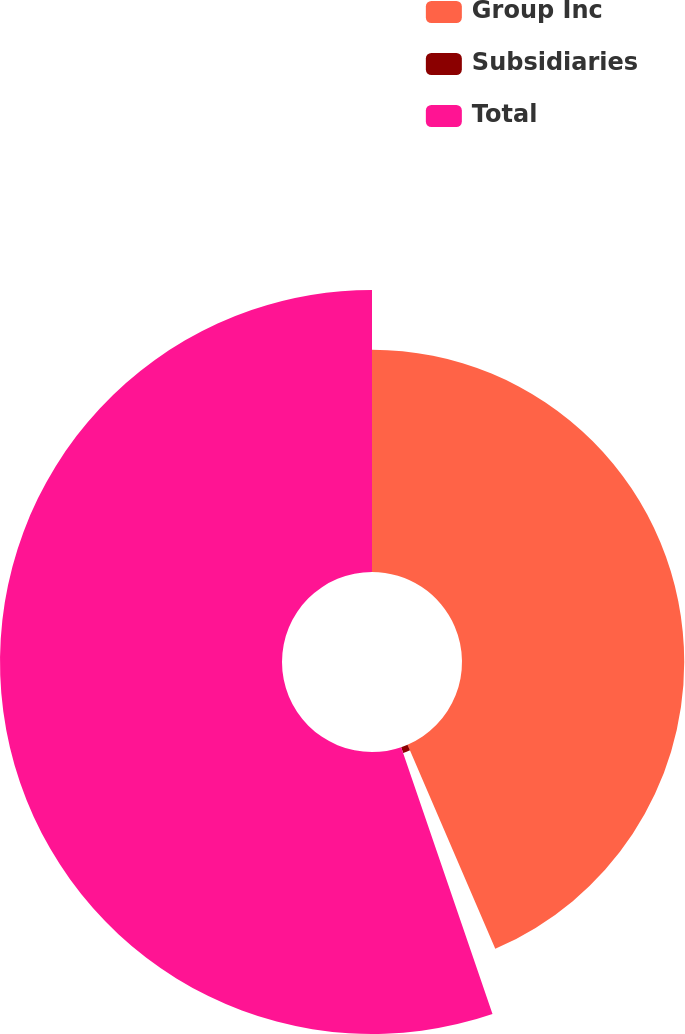Convert chart. <chart><loc_0><loc_0><loc_500><loc_500><pie_chart><fcel>Group Inc<fcel>Subsidiaries<fcel>Total<nl><fcel>43.54%<fcel>1.21%<fcel>55.25%<nl></chart> 